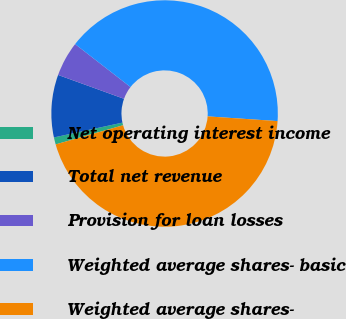<chart> <loc_0><loc_0><loc_500><loc_500><pie_chart><fcel>Net operating interest income<fcel>Total net revenue<fcel>Provision for loan losses<fcel>Weighted average shares- basic<fcel>Weighted average shares-<nl><fcel>1.01%<fcel>8.92%<fcel>4.97%<fcel>40.57%<fcel>44.53%<nl></chart> 